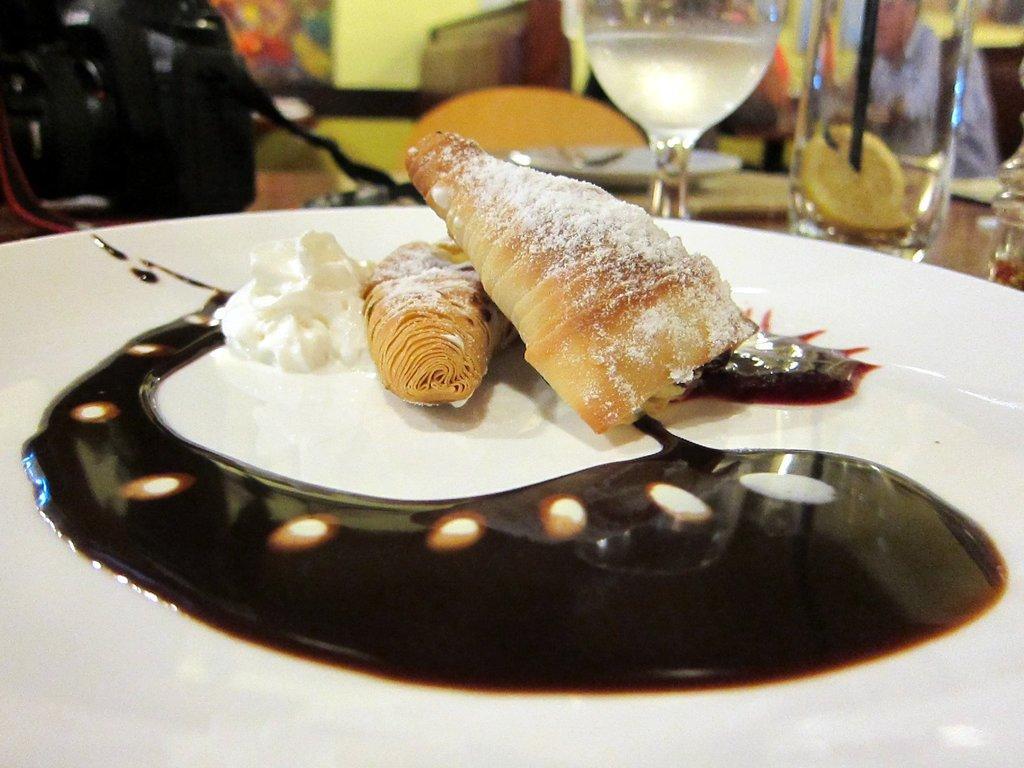In one or two sentences, can you explain what this image depicts? This image consists of a food kept on a plate. In the background, we can see the wine glasses kept on the table. On the left, it looks like a bag. On the right, we can see a person sitting. 